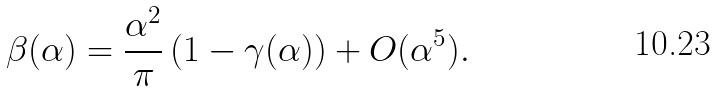<formula> <loc_0><loc_0><loc_500><loc_500>\beta ( \alpha ) = \frac { \alpha ^ { 2 } } { \pi } \left ( 1 - \gamma ( \alpha ) \right ) + O ( \alpha ^ { 5 } ) .</formula> 